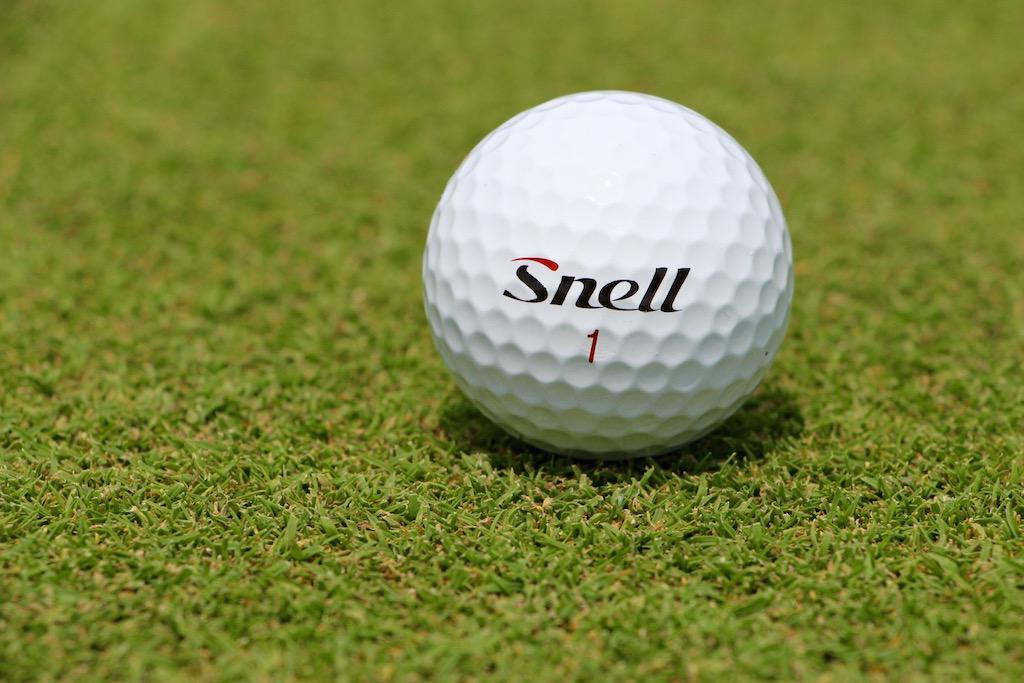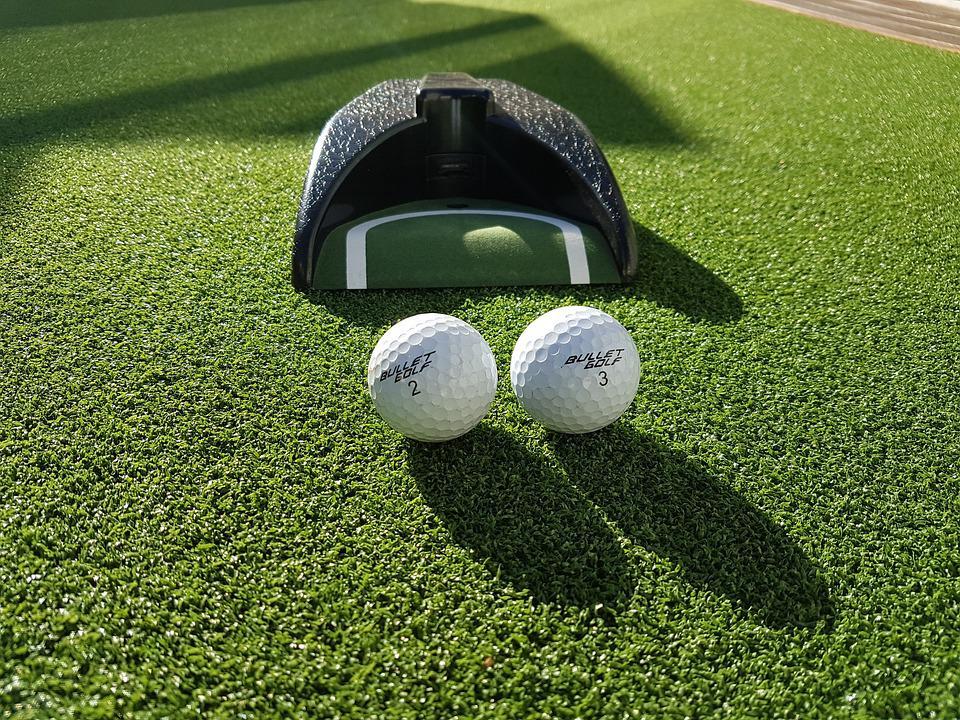The first image is the image on the left, the second image is the image on the right. Examine the images to the left and right. Is the description "two balls are placed side by side in front of a dome type cover" accurate? Answer yes or no. Yes. 